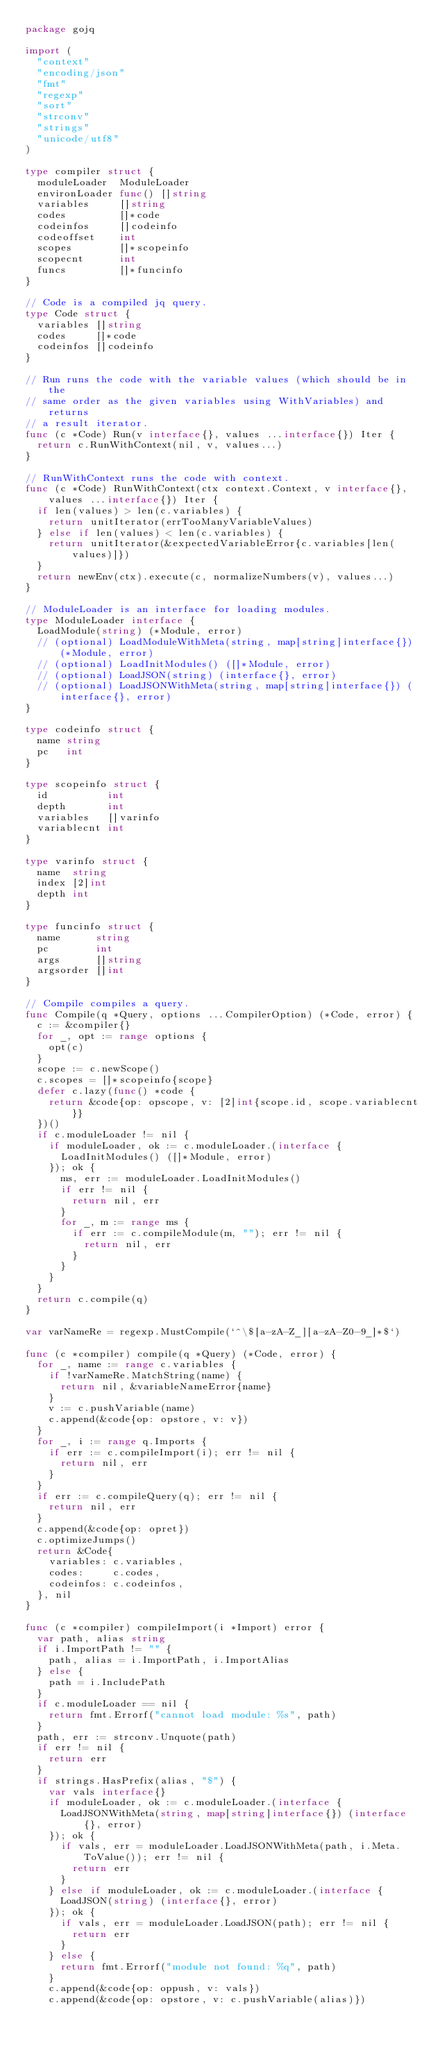Convert code to text. <code><loc_0><loc_0><loc_500><loc_500><_Go_>package gojq

import (
	"context"
	"encoding/json"
	"fmt"
	"regexp"
	"sort"
	"strconv"
	"strings"
	"unicode/utf8"
)

type compiler struct {
	moduleLoader  ModuleLoader
	environLoader func() []string
	variables     []string
	codes         []*code
	codeinfos     []codeinfo
	codeoffset    int
	scopes        []*scopeinfo
	scopecnt      int
	funcs         []*funcinfo
}

// Code is a compiled jq query.
type Code struct {
	variables []string
	codes     []*code
	codeinfos []codeinfo
}

// Run runs the code with the variable values (which should be in the
// same order as the given variables using WithVariables) and returns
// a result iterator.
func (c *Code) Run(v interface{}, values ...interface{}) Iter {
	return c.RunWithContext(nil, v, values...)
}

// RunWithContext runs the code with context.
func (c *Code) RunWithContext(ctx context.Context, v interface{}, values ...interface{}) Iter {
	if len(values) > len(c.variables) {
		return unitIterator(errTooManyVariableValues)
	} else if len(values) < len(c.variables) {
		return unitIterator(&expectedVariableError{c.variables[len(values)]})
	}
	return newEnv(ctx).execute(c, normalizeNumbers(v), values...)
}

// ModuleLoader is an interface for loading modules.
type ModuleLoader interface {
	LoadModule(string) (*Module, error)
	// (optional) LoadModuleWithMeta(string, map[string]interface{}) (*Module, error)
	// (optional) LoadInitModules() ([]*Module, error)
	// (optional) LoadJSON(string) (interface{}, error)
	// (optional) LoadJSONWithMeta(string, map[string]interface{}) (interface{}, error)
}

type codeinfo struct {
	name string
	pc   int
}

type scopeinfo struct {
	id          int
	depth       int
	variables   []varinfo
	variablecnt int
}

type varinfo struct {
	name  string
	index [2]int
	depth int
}

type funcinfo struct {
	name      string
	pc        int
	args      []string
	argsorder []int
}

// Compile compiles a query.
func Compile(q *Query, options ...CompilerOption) (*Code, error) {
	c := &compiler{}
	for _, opt := range options {
		opt(c)
	}
	scope := c.newScope()
	c.scopes = []*scopeinfo{scope}
	defer c.lazy(func() *code {
		return &code{op: opscope, v: [2]int{scope.id, scope.variablecnt}}
	})()
	if c.moduleLoader != nil {
		if moduleLoader, ok := c.moduleLoader.(interface {
			LoadInitModules() ([]*Module, error)
		}); ok {
			ms, err := moduleLoader.LoadInitModules()
			if err != nil {
				return nil, err
			}
			for _, m := range ms {
				if err := c.compileModule(m, ""); err != nil {
					return nil, err
				}
			}
		}
	}
	return c.compile(q)
}

var varNameRe = regexp.MustCompile(`^\$[a-zA-Z_][a-zA-Z0-9_]*$`)

func (c *compiler) compile(q *Query) (*Code, error) {
	for _, name := range c.variables {
		if !varNameRe.MatchString(name) {
			return nil, &variableNameError{name}
		}
		v := c.pushVariable(name)
		c.append(&code{op: opstore, v: v})
	}
	for _, i := range q.Imports {
		if err := c.compileImport(i); err != nil {
			return nil, err
		}
	}
	if err := c.compileQuery(q); err != nil {
		return nil, err
	}
	c.append(&code{op: opret})
	c.optimizeJumps()
	return &Code{
		variables: c.variables,
		codes:     c.codes,
		codeinfos: c.codeinfos,
	}, nil
}

func (c *compiler) compileImport(i *Import) error {
	var path, alias string
	if i.ImportPath != "" {
		path, alias = i.ImportPath, i.ImportAlias
	} else {
		path = i.IncludePath
	}
	if c.moduleLoader == nil {
		return fmt.Errorf("cannot load module: %s", path)
	}
	path, err := strconv.Unquote(path)
	if err != nil {
		return err
	}
	if strings.HasPrefix(alias, "$") {
		var vals interface{}
		if moduleLoader, ok := c.moduleLoader.(interface {
			LoadJSONWithMeta(string, map[string]interface{}) (interface{}, error)
		}); ok {
			if vals, err = moduleLoader.LoadJSONWithMeta(path, i.Meta.ToValue()); err != nil {
				return err
			}
		} else if moduleLoader, ok := c.moduleLoader.(interface {
			LoadJSON(string) (interface{}, error)
		}); ok {
			if vals, err = moduleLoader.LoadJSON(path); err != nil {
				return err
			}
		} else {
			return fmt.Errorf("module not found: %q", path)
		}
		c.append(&code{op: oppush, v: vals})
		c.append(&code{op: opstore, v: c.pushVariable(alias)})</code> 